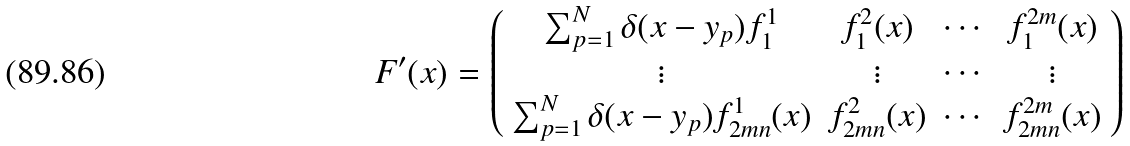<formula> <loc_0><loc_0><loc_500><loc_500>F ^ { \prime } ( x ) = \left ( \begin{array} { c c c c c } \sum _ { p = 1 } ^ { N } \delta ( x - y _ { p } ) f ^ { 1 } _ { 1 } & f _ { 1 } ^ { 2 } ( x ) & \cdots & f ^ { 2 m } _ { 1 } ( x ) \\ \vdots & \vdots & \cdots & \vdots \\ \sum _ { p = 1 } ^ { N } \delta ( x - y _ { p } ) f ^ { 1 } _ { 2 m n } ( x ) & f ^ { 2 } _ { 2 m n } ( x ) & \cdots & f ^ { 2 m } _ { 2 m n } ( x ) \end{array} \right )</formula> 